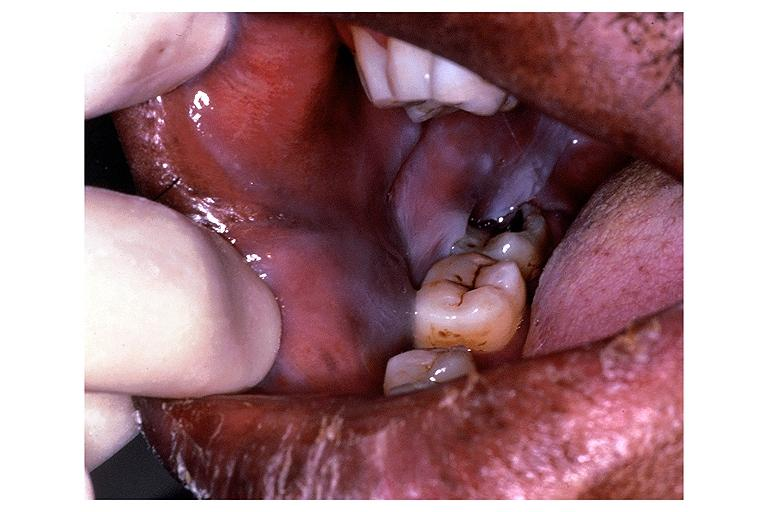s oral present?
Answer the question using a single word or phrase. Yes 